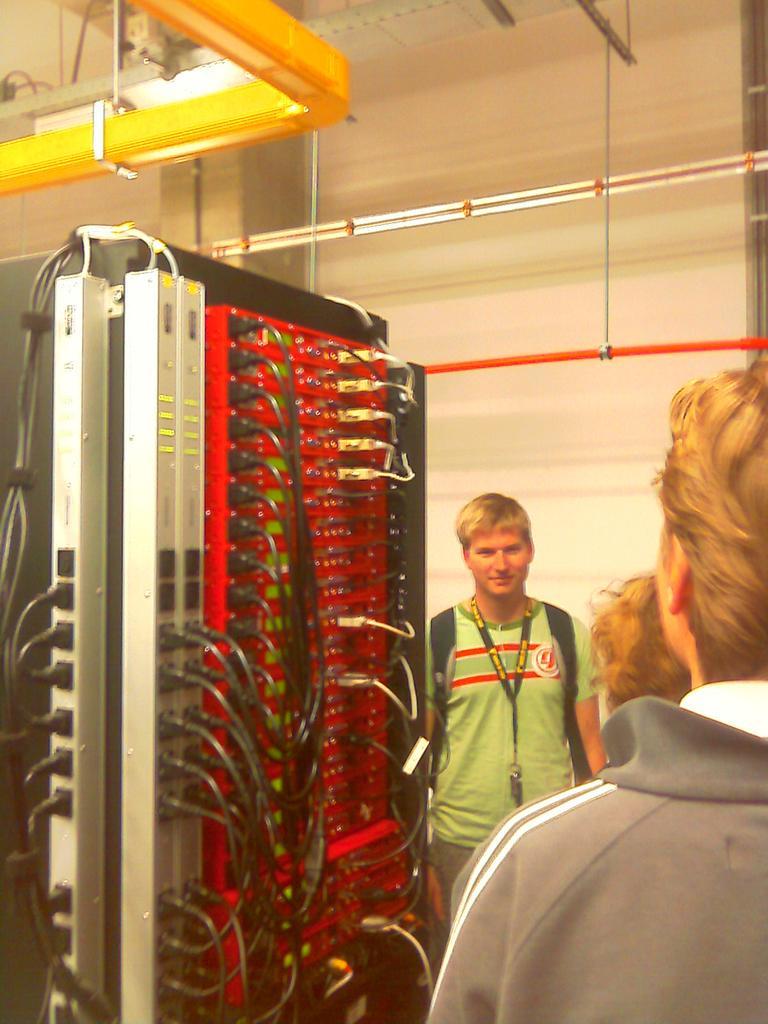How many people are in the image? There are three persons standing in the image. Where are the persons standing? The persons are standing on the floor and wires board. What can be seen in the background of the image? There is a rooftop and a wall visible in the image. What other objects can be seen in the image? There are pipes visible in the image. In which type of location was the image taken? The image was taken in a hall. How deep is the quicksand in the image? There is no quicksand present in the image. How many children are visible in the image? The image does not show any children; it features three adults standing on the floor and wires board. 